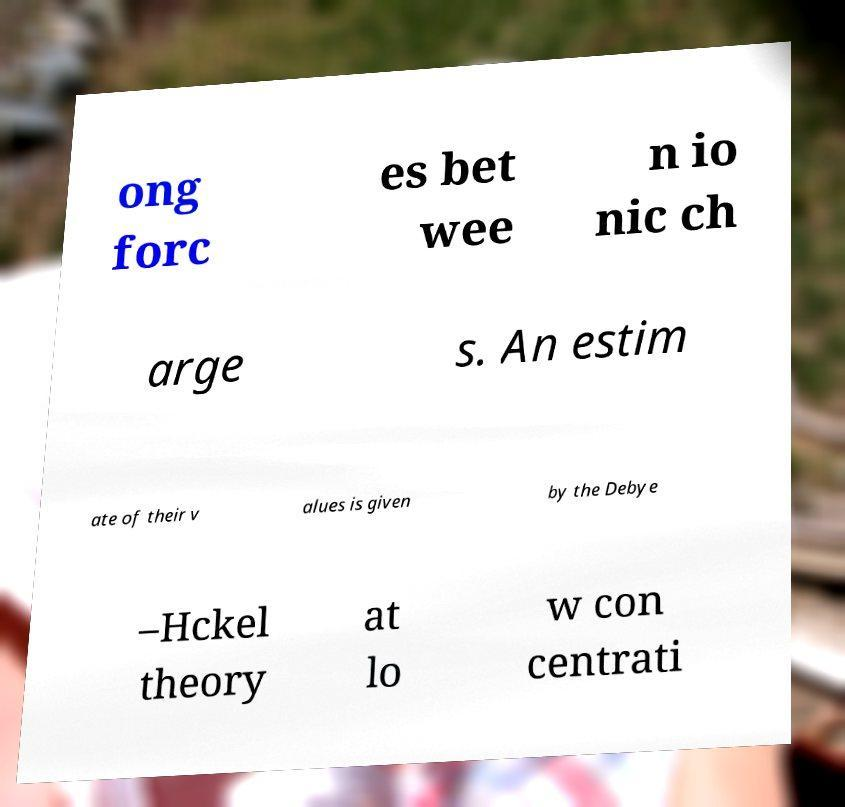I need the written content from this picture converted into text. Can you do that? ong forc es bet wee n io nic ch arge s. An estim ate of their v alues is given by the Debye –Hckel theory at lo w con centrati 